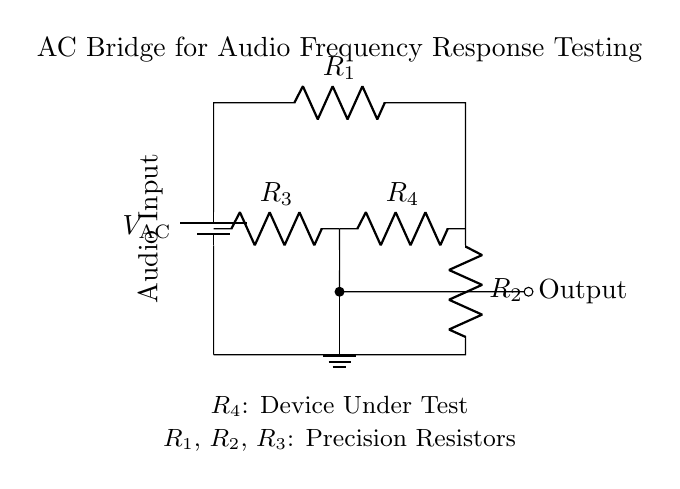What is the voltage source in the circuit? The circuit includes a voltage source labeled as V AC, which indicates the alternating current source providing the voltage.
Answer: V AC What type of components are R1, R2, and R3? R1, R2, and R3 are labeled precision resistors, which are critical for achieving accurate measurements in the bridge circuit.
Answer: Precision Resistors What does R4 represent in this circuit? R4 is labeled as the Device Under Test, indicating that it is the component whose impedance is being measured or tested in the AC bridge configuration.
Answer: Device Under Test How many resistors are present in the circuit? There are four resistors in the circuit, identified as R1, R2, R3, and R4.
Answer: Four What is the function of this circuit? The circuit is designed to test the frequency response of audio equipment, which is essential in recording studios to ensure high fidelity in sound reproduction.
Answer: Testing frequency response What impact do the precision resistors have on measurements? Precision resistors ensure that measurements are accurate and reliable because they provide consistent resistance values, minimizing errors due to resistance variations.
Answer: Minimize errors What is the significance of the ground connection in this circuit? The ground connection is essential as it establishes a reference point for the input and output signals, ensuring proper operation and safety in the testing setup.
Answer: Reference point 